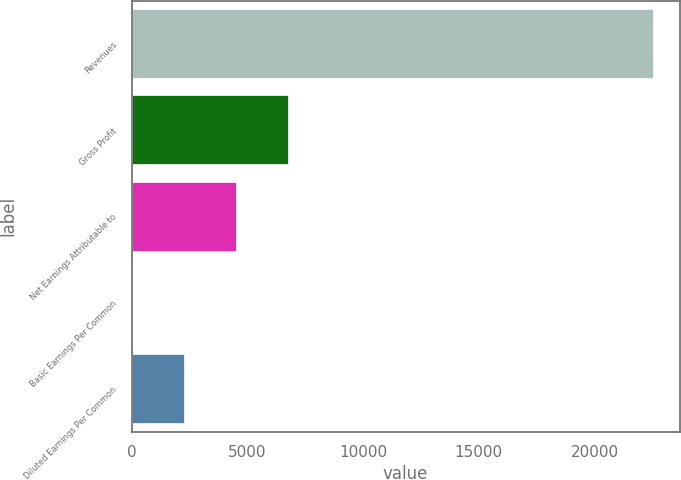Convert chart. <chart><loc_0><loc_0><loc_500><loc_500><bar_chart><fcel>Revenues<fcel>Gross Profit<fcel>Net Earnings Attributable to<fcel>Basic Earnings Per Common<fcel>Diluted Earnings Per Common<nl><fcel>22541<fcel>6762.55<fcel>4508.48<fcel>0.34<fcel>2254.41<nl></chart> 